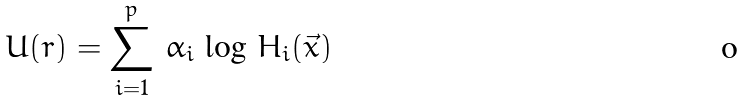Convert formula to latex. <formula><loc_0><loc_0><loc_500><loc_500>U ( r ) = \sum _ { i = 1 } ^ { p } \, \alpha _ { i } \, \log \, H _ { i } ( { \vec { x } } )</formula> 